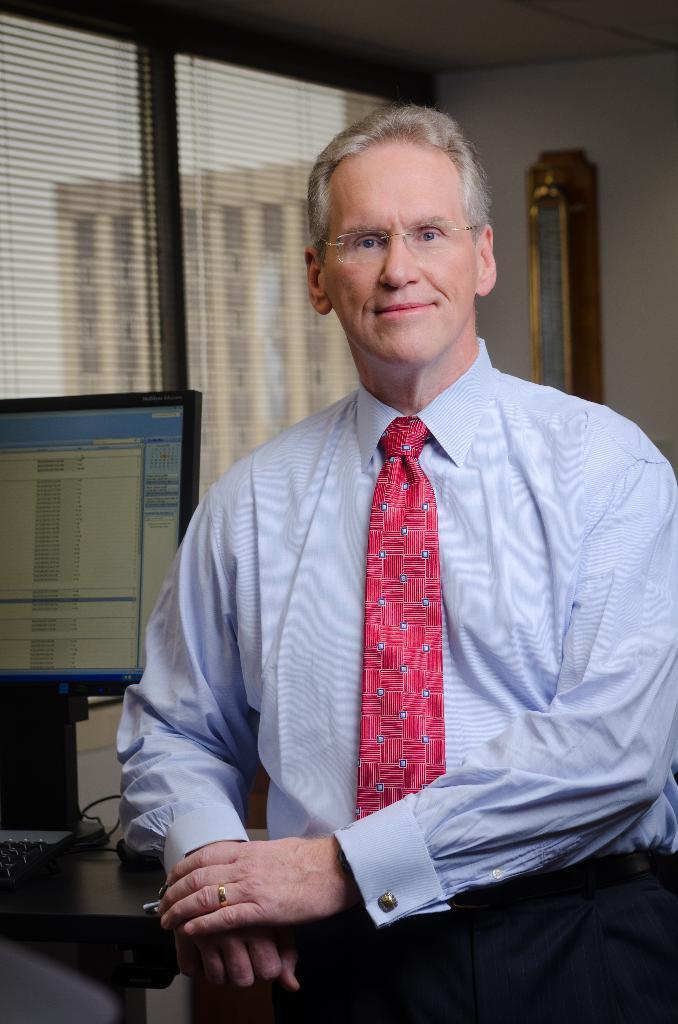Please provide a concise description of this image. In this image there is a table with monitor on it and windows in the left corner. There is a person in the foreground. There is a wall with some object on it in the background. 